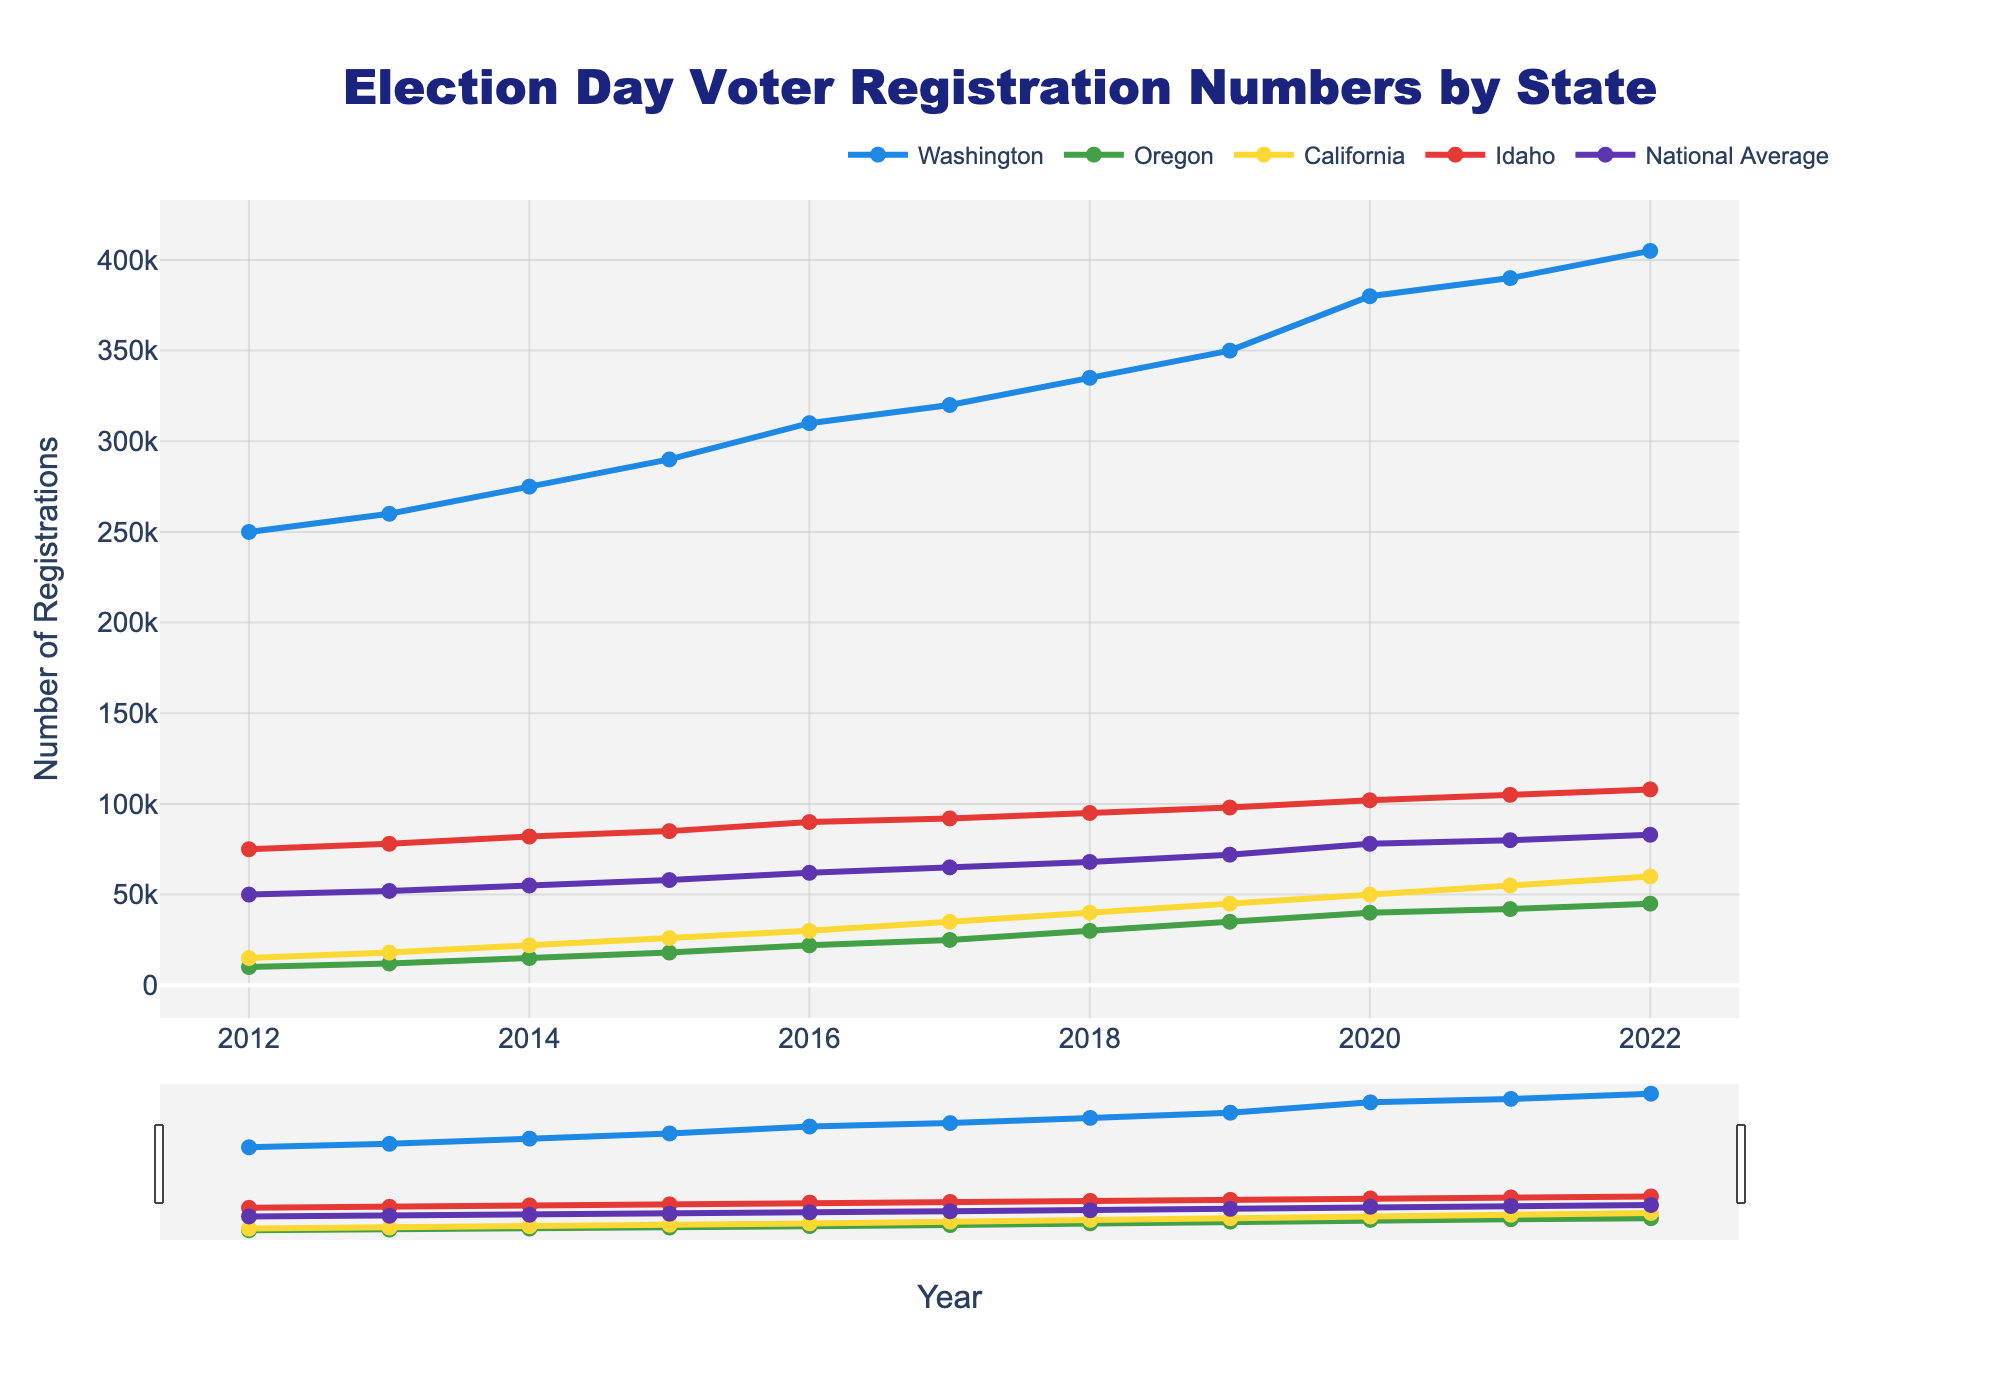Which state had the highest voter registration numbers in 2022? By examining the plot for the year 2022, the line representing Washington is the highest on the chart among all states, indicating it had the highest registration numbers.
Answer: Washington How did voter registration numbers in California in 2015 compare to those in Idaho in the same year? For the year 2015, locate the points for California and Idaho. The point for California is at 26,000 while the point for Idaho is at 85,000. So, registrations in Idaho were higher.
Answer: Idaho had higher numbers What was the trend in voter registration in Washington over the decade? Observing the line for Washington from 2012 to 2022, it shows a consistent upward trend, indicating a gradual increase in voter registration numbers each year.
Answer: Consistent Increase Which state had the smallest increase in voter registration numbers over the decade? By comparing the starting and ending points for each state, Oregon shows the smallest increase (from 10,000 in 2012 to 45,000 in 2022).
Answer: Oregon What was the average voter registration number for the National Average across all years displayed? Sum all the values for the National Average (50,000, 52,000, 55,000, 58,000, 62,000, 65,000, 68,000, 72,000, 78,000, 80,000, 83,000), then divide by the number of years (11). Sum is 693,000. Average is 693,000 / 11 = 63,000
Answer: 63,000 How did the voter registration numbers in Oregon change from 2012 to 2016? In 2012, Oregon had 10,000 registrations, and in 2016, it had 22,000. The change is 22,000 - 10,000 = 12,000.
Answer: Increased by 12,000 In which years did Idaho’s voter registration numbers surpass the National Average? Reviewing each year’s data points, Idaho’s voter registration numbers surpass the National Average from 2012 to 2022.
Answer: Every year Between which two consecutive years did Washington see the largest increase in voter registrations? Analyzing the differences year-by-year for Washington, the largest increase is between 2019 (350,000) and 2020 (380,000), a difference of 30,000.
Answer: 2019 to 2020 What was the overall trend in the National Average voter registration numbers from 2012 to 2022? Observing the National Average line, it shows a general upward trend from 2012 (50,000) to 2022 (83,000).
Answer: Upward trend Which state(s) had voter registration numbers near the National Average in 2020? Comparing the points for 2020, California (50,000) is close to the National Average (78,000) within the chart’s visual approximation.
Answer: California 